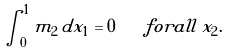Convert formula to latex. <formula><loc_0><loc_0><loc_500><loc_500>\int _ { 0 } ^ { 1 } m _ { 2 } \, d x _ { 1 } = 0 \quad f o r a l l \, x _ { 2 } .</formula> 